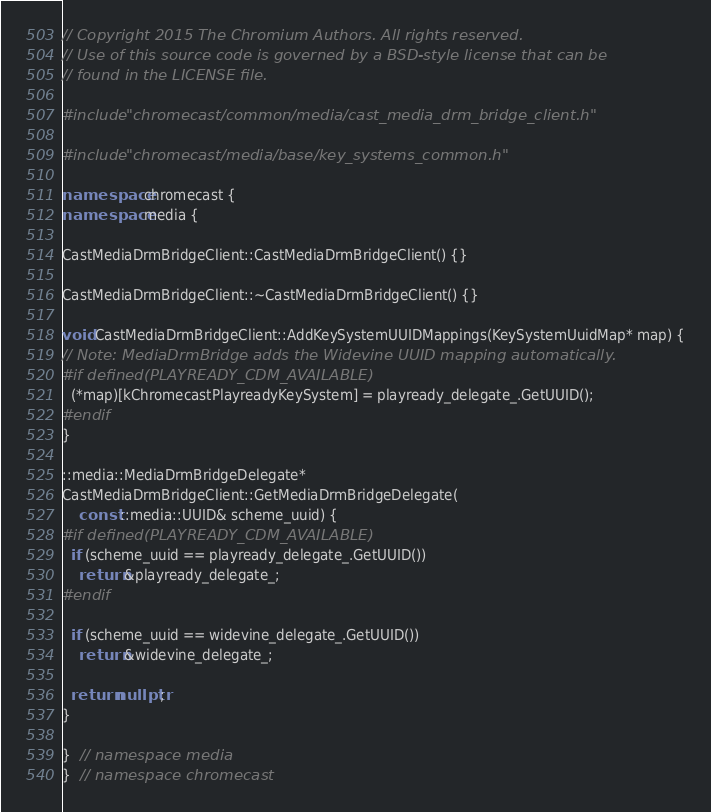Convert code to text. <code><loc_0><loc_0><loc_500><loc_500><_C++_>// Copyright 2015 The Chromium Authors. All rights reserved.
// Use of this source code is governed by a BSD-style license that can be
// found in the LICENSE file.

#include "chromecast/common/media/cast_media_drm_bridge_client.h"

#include "chromecast/media/base/key_systems_common.h"

namespace chromecast {
namespace media {

CastMediaDrmBridgeClient::CastMediaDrmBridgeClient() {}

CastMediaDrmBridgeClient::~CastMediaDrmBridgeClient() {}

void CastMediaDrmBridgeClient::AddKeySystemUUIDMappings(KeySystemUuidMap* map) {
// Note: MediaDrmBridge adds the Widevine UUID mapping automatically.
#if defined(PLAYREADY_CDM_AVAILABLE)
  (*map)[kChromecastPlayreadyKeySystem] = playready_delegate_.GetUUID();
#endif
}

::media::MediaDrmBridgeDelegate*
CastMediaDrmBridgeClient::GetMediaDrmBridgeDelegate(
    const ::media::UUID& scheme_uuid) {
#if defined(PLAYREADY_CDM_AVAILABLE)
  if (scheme_uuid == playready_delegate_.GetUUID())
    return &playready_delegate_;
#endif

  if (scheme_uuid == widevine_delegate_.GetUUID())
    return &widevine_delegate_;

  return nullptr;
}

}  // namespace media
}  // namespace chromecast
</code> 